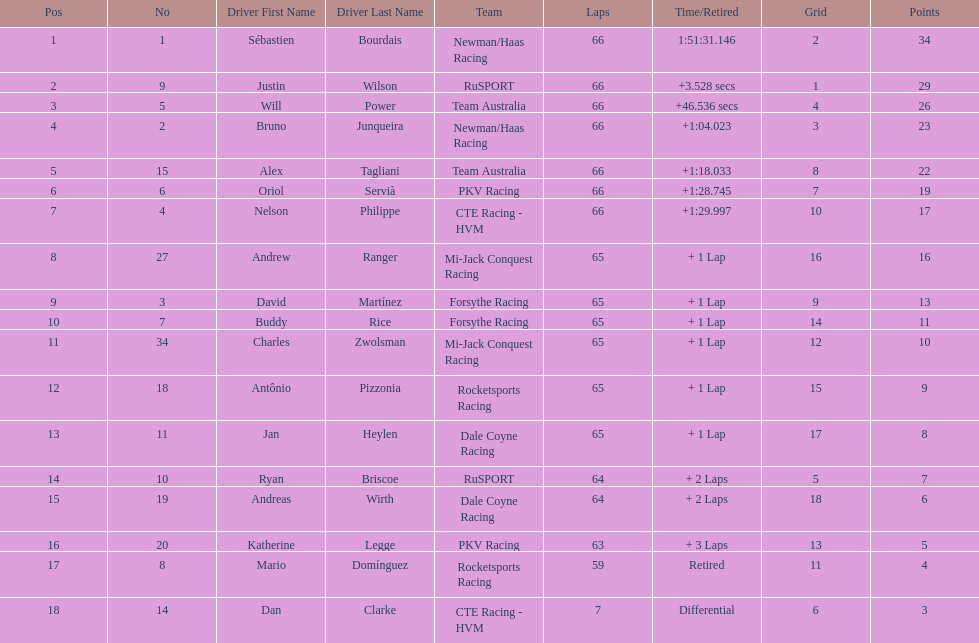Who are all the drivers? Sébastien Bourdais, Justin Wilson, Will Power, Bruno Junqueira, Alex Tagliani, Oriol Servià, Nelson Philippe, Andrew Ranger, David Martínez, Buddy Rice, Charles Zwolsman, Antônio Pizzonia, Jan Heylen, Ryan Briscoe, Andreas Wirth, Katherine Legge, Mario Domínguez, Dan Clarke. What position did they reach? 1, 2, 3, 4, 5, 6, 7, 8, 9, 10, 11, 12, 13, 14, 15, 16, 17, 18. What is the number for each driver? 1, 9, 5, 2, 15, 6, 4, 27, 3, 7, 34, 18, 11, 10, 19, 20, 8, 14. And which player's number and position match? Sébastien Bourdais. 